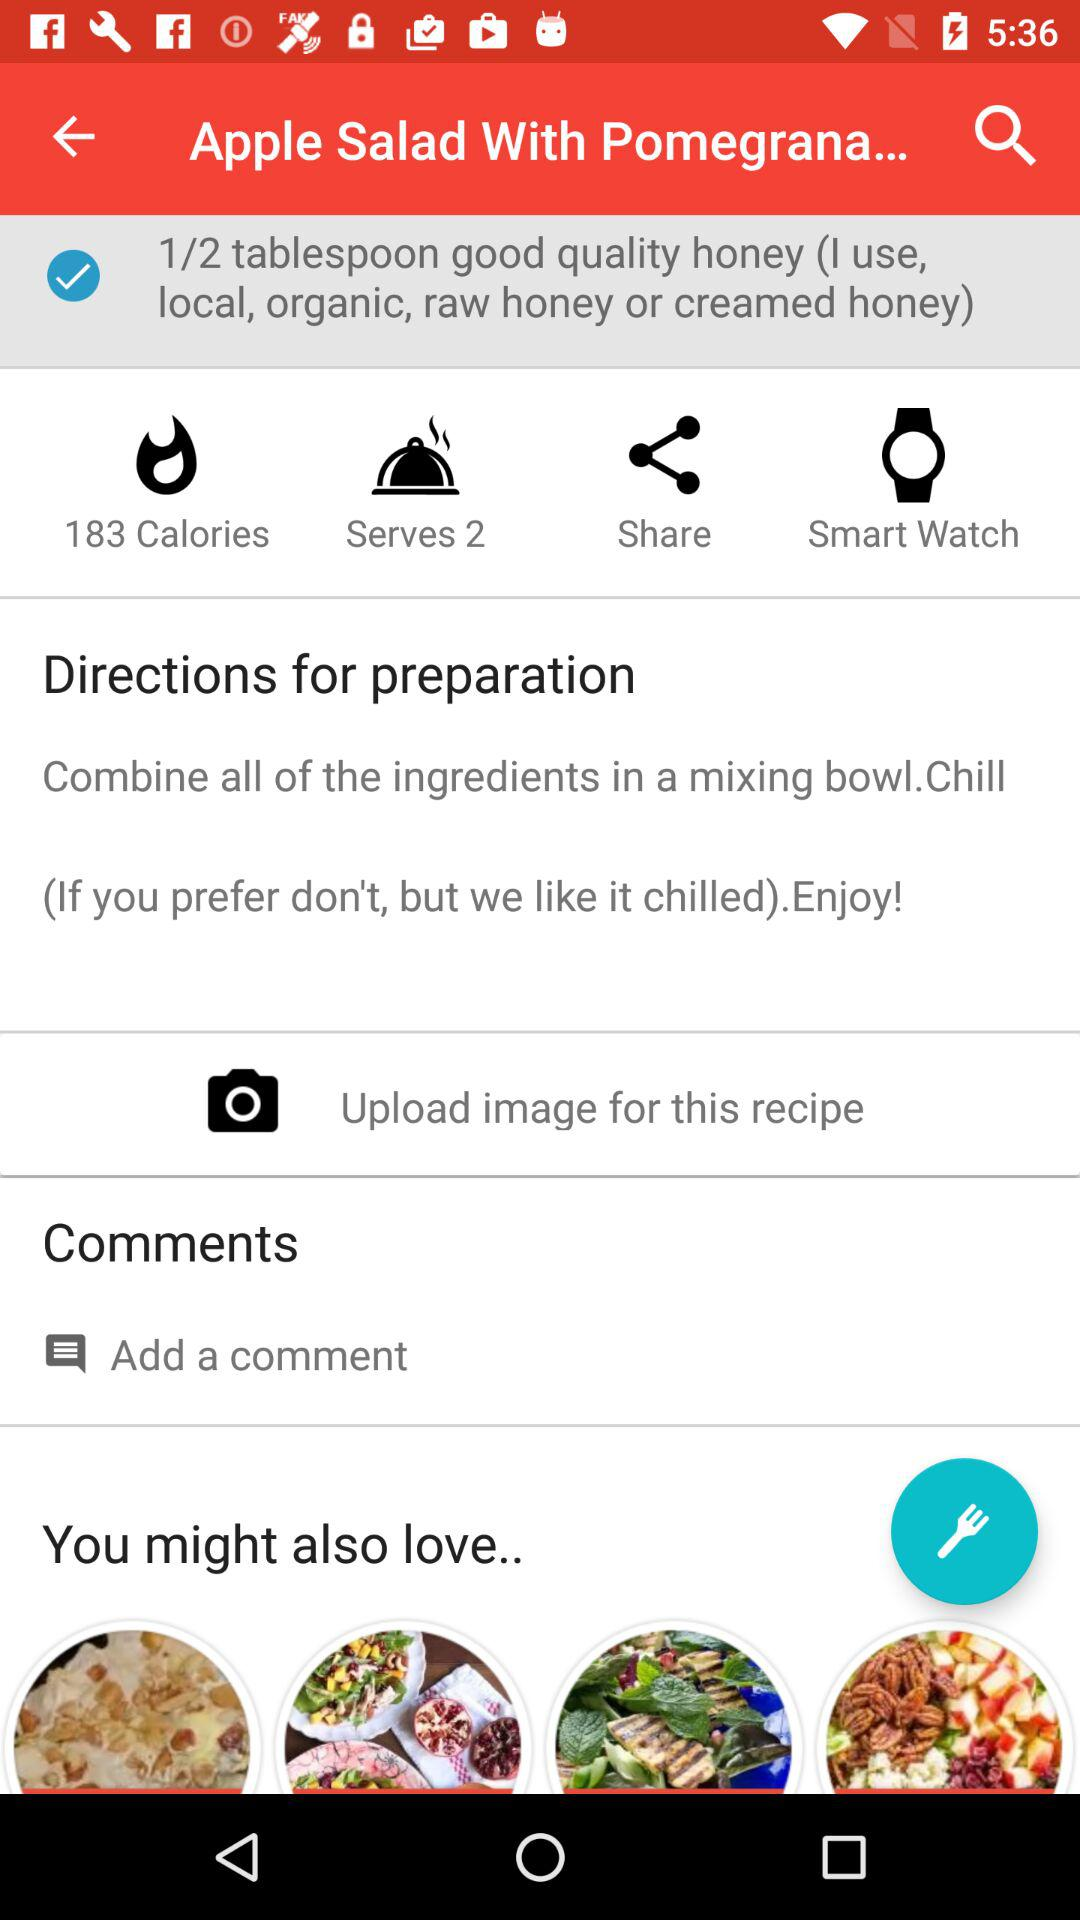What is the quantity of honey in the dish? The quantity of honey in the dish is 1/2 tablespoon. 